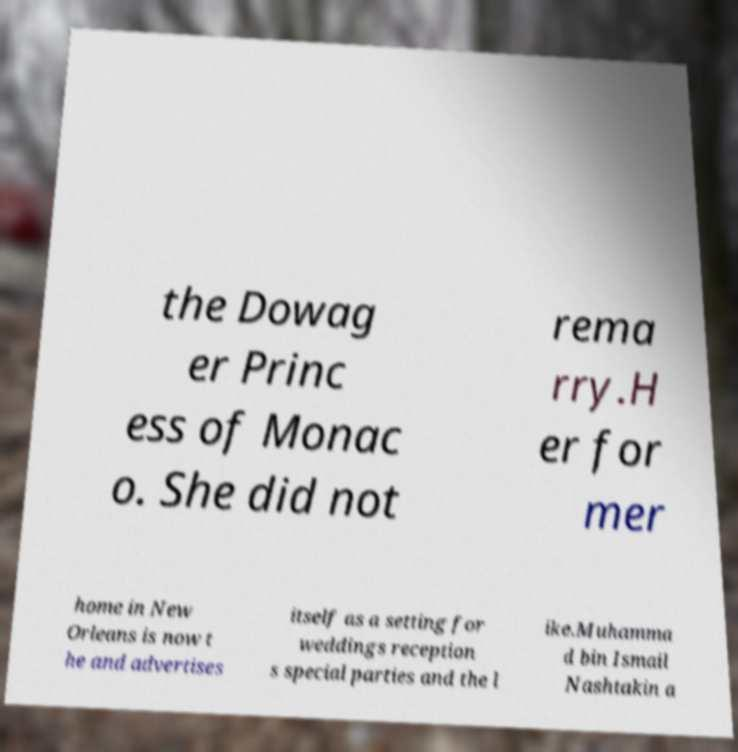For documentation purposes, I need the text within this image transcribed. Could you provide that? the Dowag er Princ ess of Monac o. She did not rema rry.H er for mer home in New Orleans is now t he and advertises itself as a setting for weddings reception s special parties and the l ike.Muhamma d bin Ismail Nashtakin a 